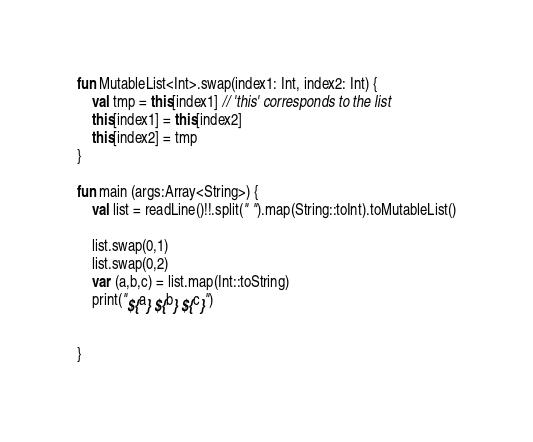Convert code to text. <code><loc_0><loc_0><loc_500><loc_500><_Kotlin_>fun MutableList<Int>.swap(index1: Int, index2: Int) {
    val tmp = this[index1] // 'this' corresponds to the list
    this[index1] = this[index2]
    this[index2] = tmp
}

fun main (args:Array<String>) {
    val list = readLine()!!.split(" ").map(String::toInt).toMutableList()

    list.swap(0,1)
    list.swap(0,2)
    var (a,b,c) = list.map(Int::toString)
    print("${a} ${b} ${c}")


}
</code> 